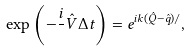Convert formula to latex. <formula><loc_0><loc_0><loc_500><loc_500>\exp \left ( - \frac { i } { } \hat { V } \Delta t \right ) = e ^ { i k ( \hat { Q } - \hat { q } ) / } ,</formula> 